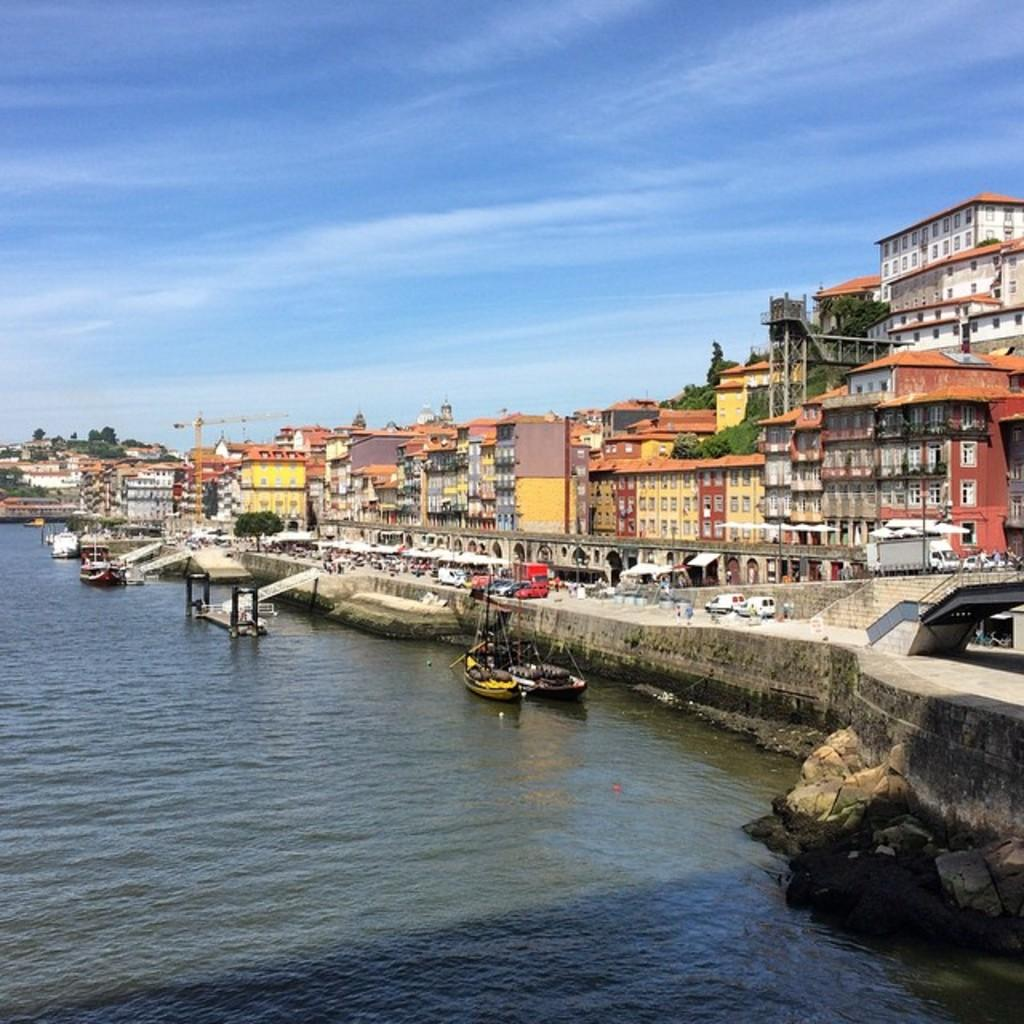What is on the water in the image? There are boats on the water in the image. What can be seen on the right side of the boats? There are vehicles, buildings, trees, and a crane on the right side of the boats. What is visible in the sky in the image? The sky is visible in the image. How many pins are holding the doll's hair in the image? There is no doll or pins present in the image. What type of rings can be seen on the fingers of the people in the image? There are no people or rings visible in the image. 